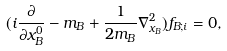Convert formula to latex. <formula><loc_0><loc_0><loc_500><loc_500>( i \frac { \partial } { \partial x ^ { 0 } _ { B } } - m _ { B } + \frac { 1 } { 2 m _ { B } } { \nabla } ^ { 2 } _ { x _ { B } } ) f _ { B ; i } = 0 ,</formula> 